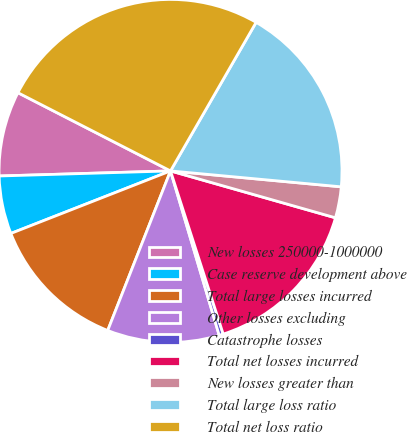<chart> <loc_0><loc_0><loc_500><loc_500><pie_chart><fcel>New losses 250000-1000000<fcel>Case reserve development above<fcel>Total large losses incurred<fcel>Other losses excluding<fcel>Catastrophe losses<fcel>Total net losses incurred<fcel>New losses greater than<fcel>Total large loss ratio<fcel>Total net loss ratio<nl><fcel>8.01%<fcel>5.47%<fcel>13.09%<fcel>10.55%<fcel>0.39%<fcel>15.62%<fcel>2.93%<fcel>18.16%<fcel>25.78%<nl></chart> 